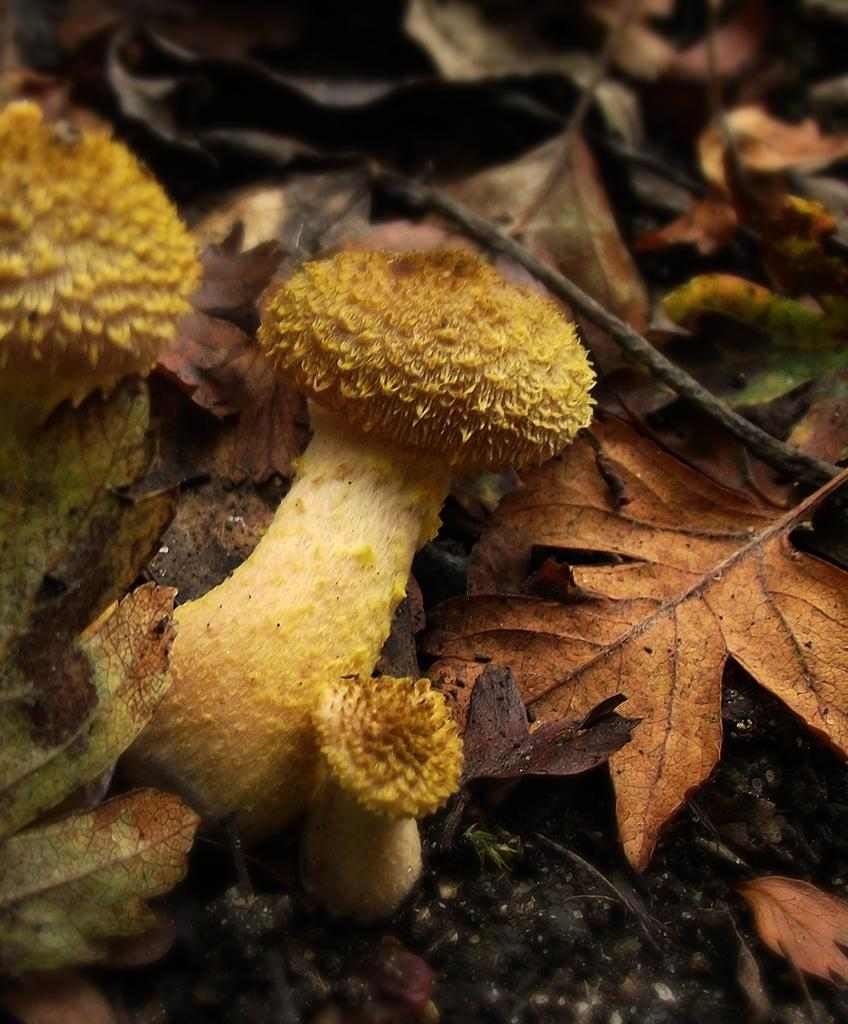What type of fungi can be seen in the image? There are mushrooms in the image. What type of plant material is present in the image? There are dried leaves in the image. Can you see any deer in the image? There are no deer present in the image. What type of weather condition is depicted in the image? The provided facts do not mention any weather conditions, so it cannot be determined from the image. 